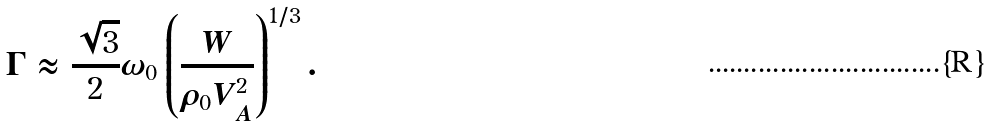Convert formula to latex. <formula><loc_0><loc_0><loc_500><loc_500>\Gamma \approx \frac { \sqrt { 3 } } { 2 } \omega _ { 0 } \left ( \frac { W } { \rho _ { 0 } V _ { A } ^ { 2 } } \right ) ^ { 1 / 3 } .</formula> 